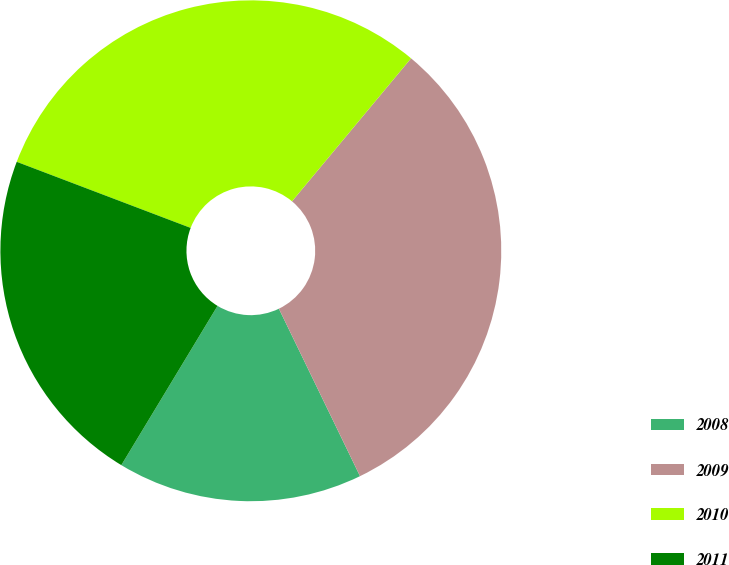Convert chart to OTSL. <chart><loc_0><loc_0><loc_500><loc_500><pie_chart><fcel>2008<fcel>2009<fcel>2010<fcel>2011<nl><fcel>15.83%<fcel>31.77%<fcel>30.27%<fcel>22.13%<nl></chart> 